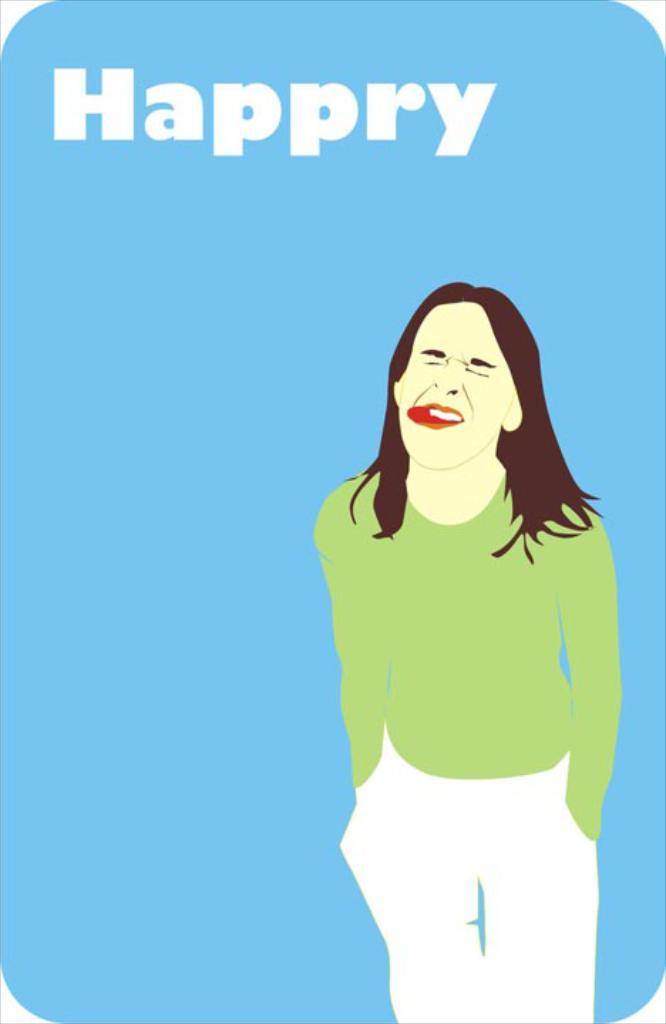<image>
Render a clear and concise summary of the photo. Poster showing a woman with her tongue out and a word that says Happry. 